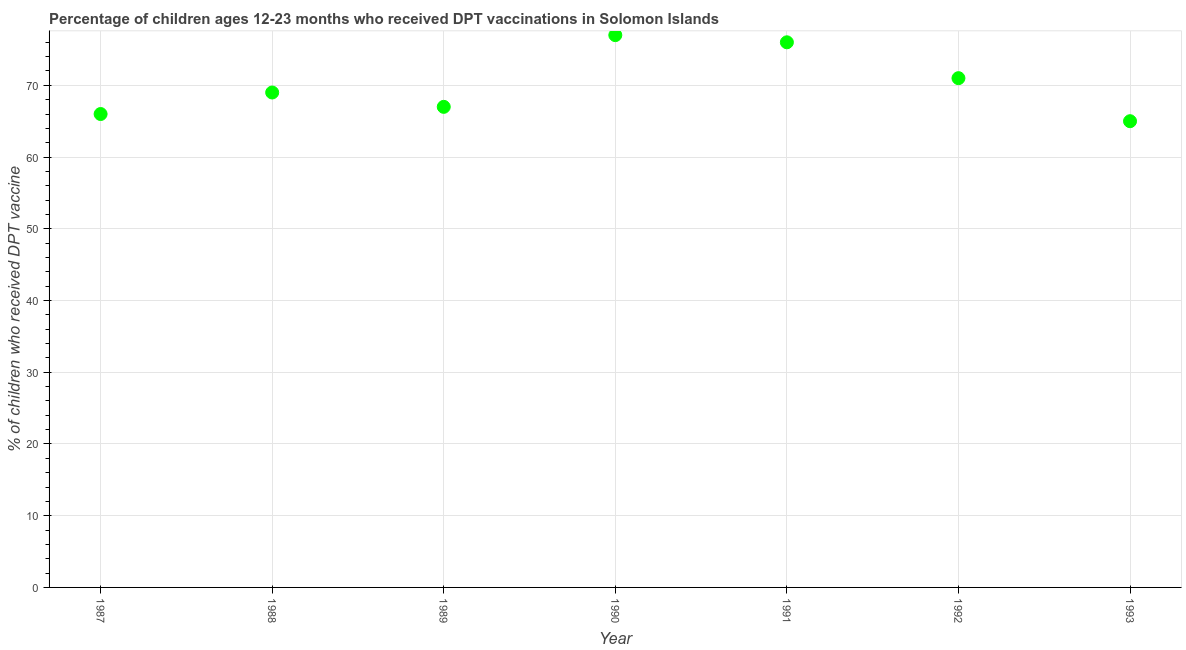What is the percentage of children who received dpt vaccine in 1987?
Give a very brief answer. 66. Across all years, what is the maximum percentage of children who received dpt vaccine?
Make the answer very short. 77. Across all years, what is the minimum percentage of children who received dpt vaccine?
Ensure brevity in your answer.  65. In which year was the percentage of children who received dpt vaccine maximum?
Make the answer very short. 1990. What is the sum of the percentage of children who received dpt vaccine?
Give a very brief answer. 491. What is the difference between the percentage of children who received dpt vaccine in 1990 and 1993?
Provide a succinct answer. 12. What is the average percentage of children who received dpt vaccine per year?
Keep it short and to the point. 70.14. In how many years, is the percentage of children who received dpt vaccine greater than 12 %?
Your answer should be very brief. 7. Do a majority of the years between 1992 and 1993 (inclusive) have percentage of children who received dpt vaccine greater than 8 %?
Offer a very short reply. Yes. What is the ratio of the percentage of children who received dpt vaccine in 1989 to that in 1992?
Provide a short and direct response. 0.94. Is the difference between the percentage of children who received dpt vaccine in 1989 and 1991 greater than the difference between any two years?
Provide a short and direct response. No. Is the sum of the percentage of children who received dpt vaccine in 1987 and 1988 greater than the maximum percentage of children who received dpt vaccine across all years?
Give a very brief answer. Yes. What is the difference between the highest and the lowest percentage of children who received dpt vaccine?
Your response must be concise. 12. In how many years, is the percentage of children who received dpt vaccine greater than the average percentage of children who received dpt vaccine taken over all years?
Keep it short and to the point. 3. Does the percentage of children who received dpt vaccine monotonically increase over the years?
Make the answer very short. No. How many dotlines are there?
Keep it short and to the point. 1. What is the difference between two consecutive major ticks on the Y-axis?
Your answer should be compact. 10. Does the graph contain any zero values?
Give a very brief answer. No. What is the title of the graph?
Offer a terse response. Percentage of children ages 12-23 months who received DPT vaccinations in Solomon Islands. What is the label or title of the Y-axis?
Offer a terse response. % of children who received DPT vaccine. What is the % of children who received DPT vaccine in 1988?
Keep it short and to the point. 69. What is the % of children who received DPT vaccine in 1989?
Offer a terse response. 67. What is the % of children who received DPT vaccine in 1990?
Provide a succinct answer. 77. What is the % of children who received DPT vaccine in 1991?
Give a very brief answer. 76. What is the difference between the % of children who received DPT vaccine in 1988 and 1989?
Make the answer very short. 2. What is the difference between the % of children who received DPT vaccine in 1988 and 1991?
Your answer should be very brief. -7. What is the difference between the % of children who received DPT vaccine in 1988 and 1992?
Offer a terse response. -2. What is the difference between the % of children who received DPT vaccine in 1989 and 1991?
Your response must be concise. -9. What is the difference between the % of children who received DPT vaccine in 1990 and 1991?
Offer a very short reply. 1. What is the difference between the % of children who received DPT vaccine in 1990 and 1992?
Your answer should be compact. 6. What is the difference between the % of children who received DPT vaccine in 1991 and 1992?
Keep it short and to the point. 5. What is the difference between the % of children who received DPT vaccine in 1992 and 1993?
Provide a succinct answer. 6. What is the ratio of the % of children who received DPT vaccine in 1987 to that in 1988?
Your response must be concise. 0.96. What is the ratio of the % of children who received DPT vaccine in 1987 to that in 1990?
Your answer should be compact. 0.86. What is the ratio of the % of children who received DPT vaccine in 1987 to that in 1991?
Keep it short and to the point. 0.87. What is the ratio of the % of children who received DPT vaccine in 1987 to that in 1992?
Ensure brevity in your answer.  0.93. What is the ratio of the % of children who received DPT vaccine in 1987 to that in 1993?
Your answer should be very brief. 1.01. What is the ratio of the % of children who received DPT vaccine in 1988 to that in 1989?
Provide a succinct answer. 1.03. What is the ratio of the % of children who received DPT vaccine in 1988 to that in 1990?
Provide a short and direct response. 0.9. What is the ratio of the % of children who received DPT vaccine in 1988 to that in 1991?
Ensure brevity in your answer.  0.91. What is the ratio of the % of children who received DPT vaccine in 1988 to that in 1993?
Ensure brevity in your answer.  1.06. What is the ratio of the % of children who received DPT vaccine in 1989 to that in 1990?
Keep it short and to the point. 0.87. What is the ratio of the % of children who received DPT vaccine in 1989 to that in 1991?
Provide a succinct answer. 0.88. What is the ratio of the % of children who received DPT vaccine in 1989 to that in 1992?
Provide a short and direct response. 0.94. What is the ratio of the % of children who received DPT vaccine in 1989 to that in 1993?
Your answer should be compact. 1.03. What is the ratio of the % of children who received DPT vaccine in 1990 to that in 1991?
Give a very brief answer. 1.01. What is the ratio of the % of children who received DPT vaccine in 1990 to that in 1992?
Offer a terse response. 1.08. What is the ratio of the % of children who received DPT vaccine in 1990 to that in 1993?
Give a very brief answer. 1.19. What is the ratio of the % of children who received DPT vaccine in 1991 to that in 1992?
Your response must be concise. 1.07. What is the ratio of the % of children who received DPT vaccine in 1991 to that in 1993?
Your answer should be very brief. 1.17. What is the ratio of the % of children who received DPT vaccine in 1992 to that in 1993?
Offer a very short reply. 1.09. 